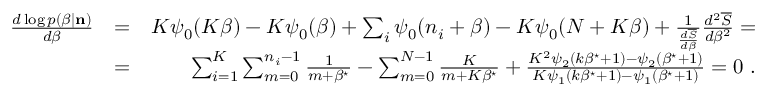Convert formula to latex. <formula><loc_0><loc_0><loc_500><loc_500>\begin{array} { r l r } { \frac { d \log p ( \beta | { n } ) } { d \beta } } & { = } & { K \psi _ { 0 } ( K \beta ) - K \psi _ { 0 } ( \beta ) + \sum _ { i } \psi _ { 0 } ( n _ { i } + \beta ) - K \psi _ { 0 } ( N + K \beta ) + \frac { 1 } { \frac { d \overline { S } } { d \beta } } \frac { d ^ { 2 } \overline { S } } { d \beta ^ { 2 } } = } \\ & { = } & { \sum _ { i = 1 } ^ { K } \sum _ { m = 0 } ^ { n _ { i } - 1 } \frac { 1 } { m + \beta ^ { ^ { * } } } - \sum _ { m = 0 } ^ { N - 1 } \frac { K } { m + K \beta ^ { ^ { * } } } + \frac { K ^ { 2 } \psi _ { 2 } ( k \beta ^ { ^ { * } } + 1 ) - \psi _ { 2 } ( \beta ^ { ^ { * } } + 1 ) } { K \psi _ { 1 } ( k \beta ^ { ^ { * } } + 1 ) - \psi _ { 1 } ( \beta ^ { ^ { * } } + 1 ) } = 0 . } \end{array}</formula> 